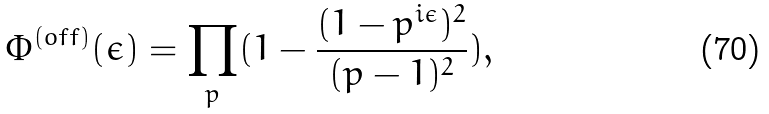<formula> <loc_0><loc_0><loc_500><loc_500>\Phi ^ { ( o f f ) } ( \epsilon ) = \prod _ { p } ( 1 - \frac { ( 1 - p ^ { i \epsilon } ) ^ { 2 } } { ( p - 1 ) ^ { 2 } } ) ,</formula> 